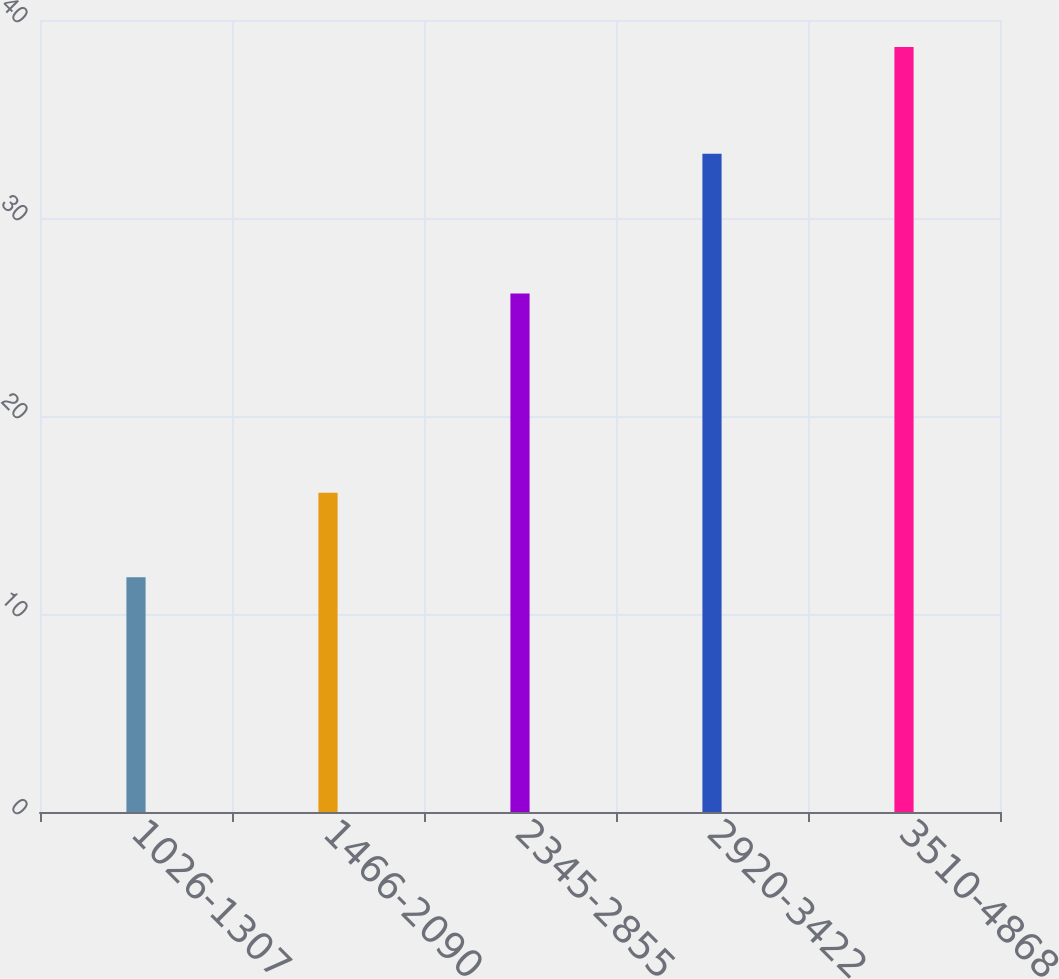<chart> <loc_0><loc_0><loc_500><loc_500><bar_chart><fcel>1026-1307<fcel>1466-2090<fcel>2345-2855<fcel>2920-3422<fcel>3510-4868<nl><fcel>11.85<fcel>16.12<fcel>26.19<fcel>33.25<fcel>38.64<nl></chart> 